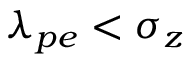Convert formula to latex. <formula><loc_0><loc_0><loc_500><loc_500>\lambda _ { p e } < \sigma _ { z }</formula> 